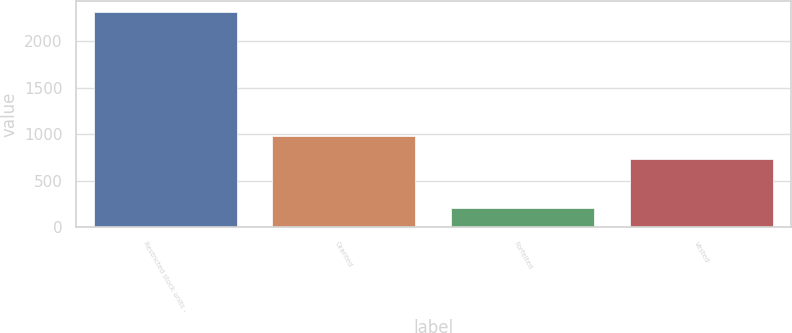Convert chart to OTSL. <chart><loc_0><loc_0><loc_500><loc_500><bar_chart><fcel>Restricted stock units -<fcel>Granted<fcel>Forfeited<fcel>Vested<nl><fcel>2315.3<fcel>977<fcel>204<fcel>736<nl></chart> 